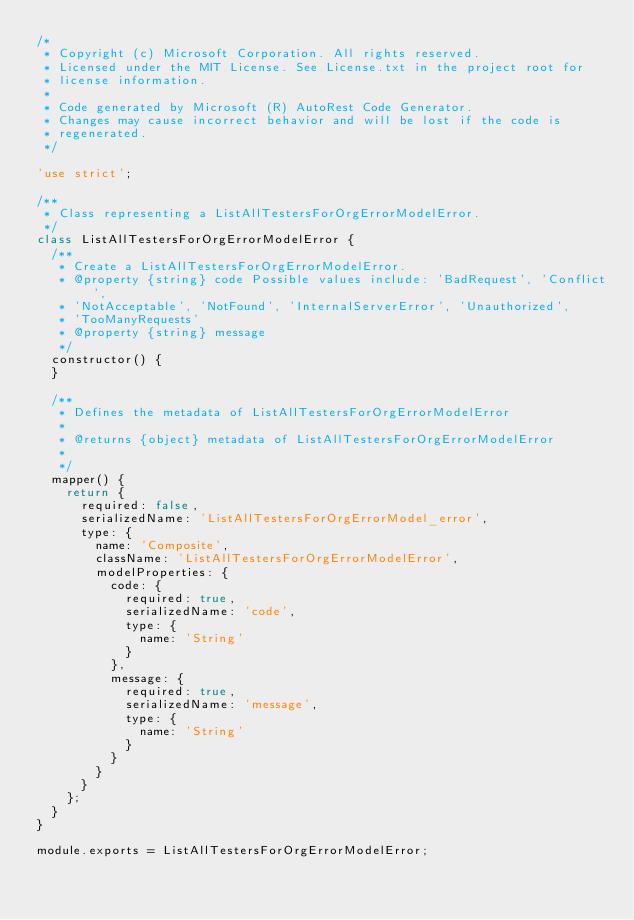Convert code to text. <code><loc_0><loc_0><loc_500><loc_500><_JavaScript_>/*
 * Copyright (c) Microsoft Corporation. All rights reserved.
 * Licensed under the MIT License. See License.txt in the project root for
 * license information.
 *
 * Code generated by Microsoft (R) AutoRest Code Generator.
 * Changes may cause incorrect behavior and will be lost if the code is
 * regenerated.
 */

'use strict';

/**
 * Class representing a ListAllTestersForOrgErrorModelError.
 */
class ListAllTestersForOrgErrorModelError {
  /**
   * Create a ListAllTestersForOrgErrorModelError.
   * @property {string} code Possible values include: 'BadRequest', 'Conflict',
   * 'NotAcceptable', 'NotFound', 'InternalServerError', 'Unauthorized',
   * 'TooManyRequests'
   * @property {string} message
   */
  constructor() {
  }

  /**
   * Defines the metadata of ListAllTestersForOrgErrorModelError
   *
   * @returns {object} metadata of ListAllTestersForOrgErrorModelError
   *
   */
  mapper() {
    return {
      required: false,
      serializedName: 'ListAllTestersForOrgErrorModel_error',
      type: {
        name: 'Composite',
        className: 'ListAllTestersForOrgErrorModelError',
        modelProperties: {
          code: {
            required: true,
            serializedName: 'code',
            type: {
              name: 'String'
            }
          },
          message: {
            required: true,
            serializedName: 'message',
            type: {
              name: 'String'
            }
          }
        }
      }
    };
  }
}

module.exports = ListAllTestersForOrgErrorModelError;
</code> 